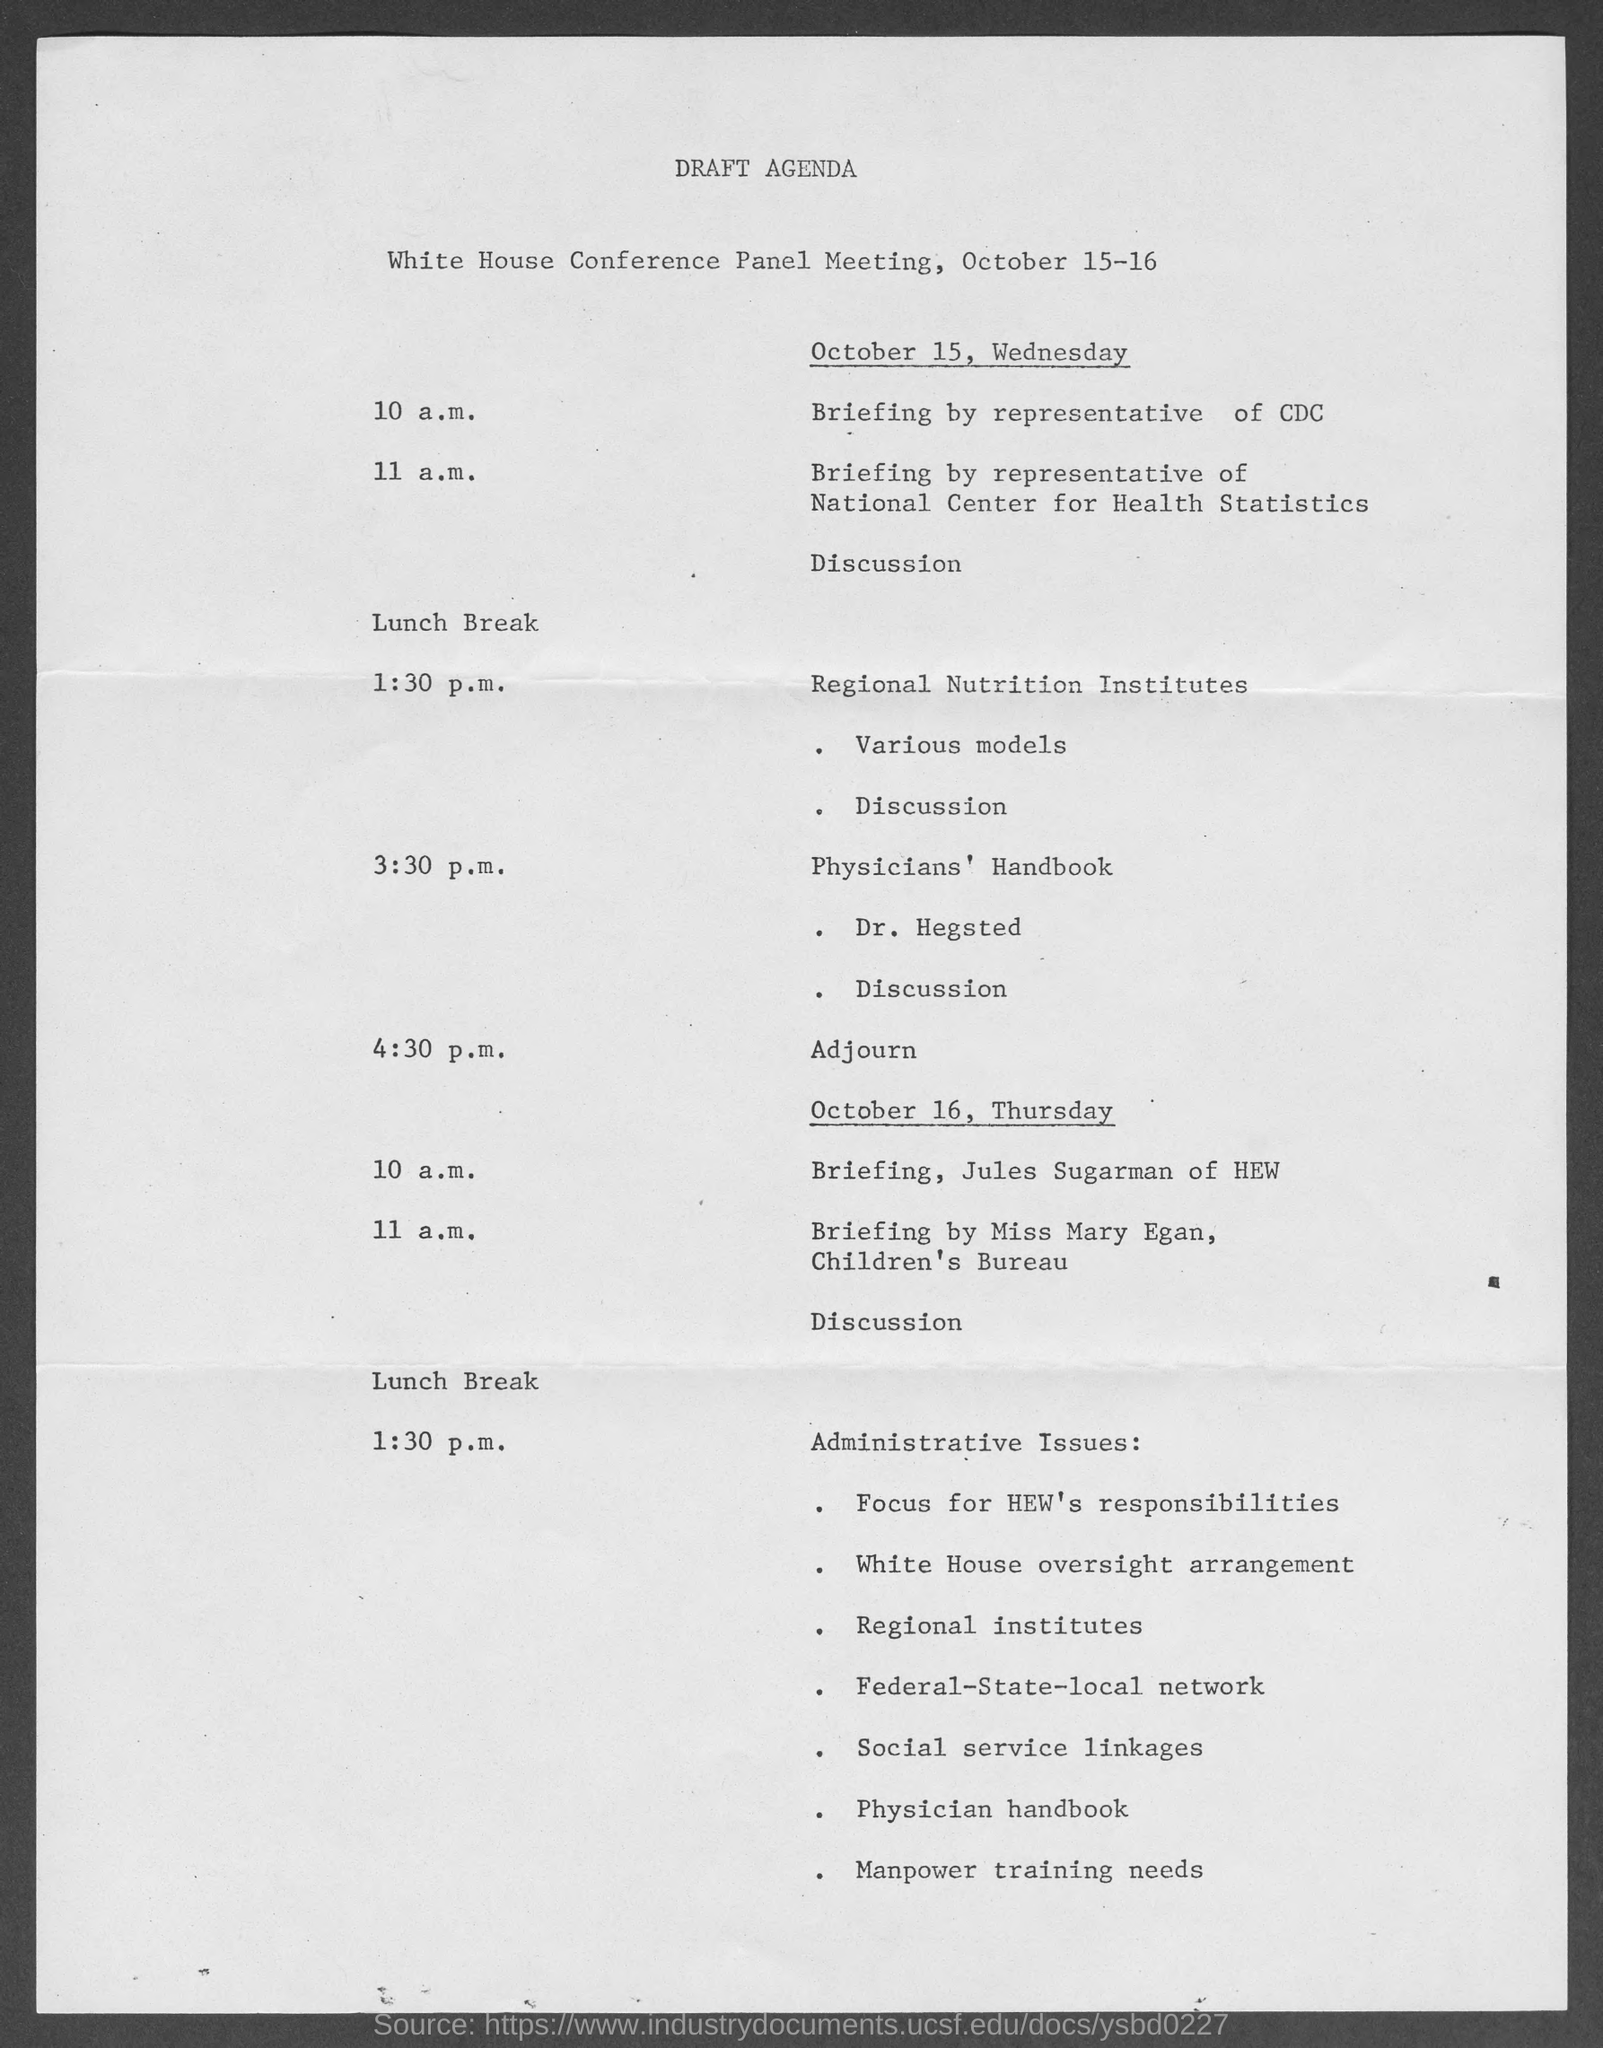What is the document title?
Offer a terse response. Draft agenda. When is the meeting going to be held?
Provide a short and direct response. October 15-16. What is the event at 10 a.m. on October 15?
Provide a succinct answer. Briefing by representative of CDC. Who is involved in the discussion of Physicians' Handbook?
Give a very brief answer. Dr. Hegsted. What is the event at 11 a.m. on October 16?
Ensure brevity in your answer.  Briefing by Miss Mary Egan. 